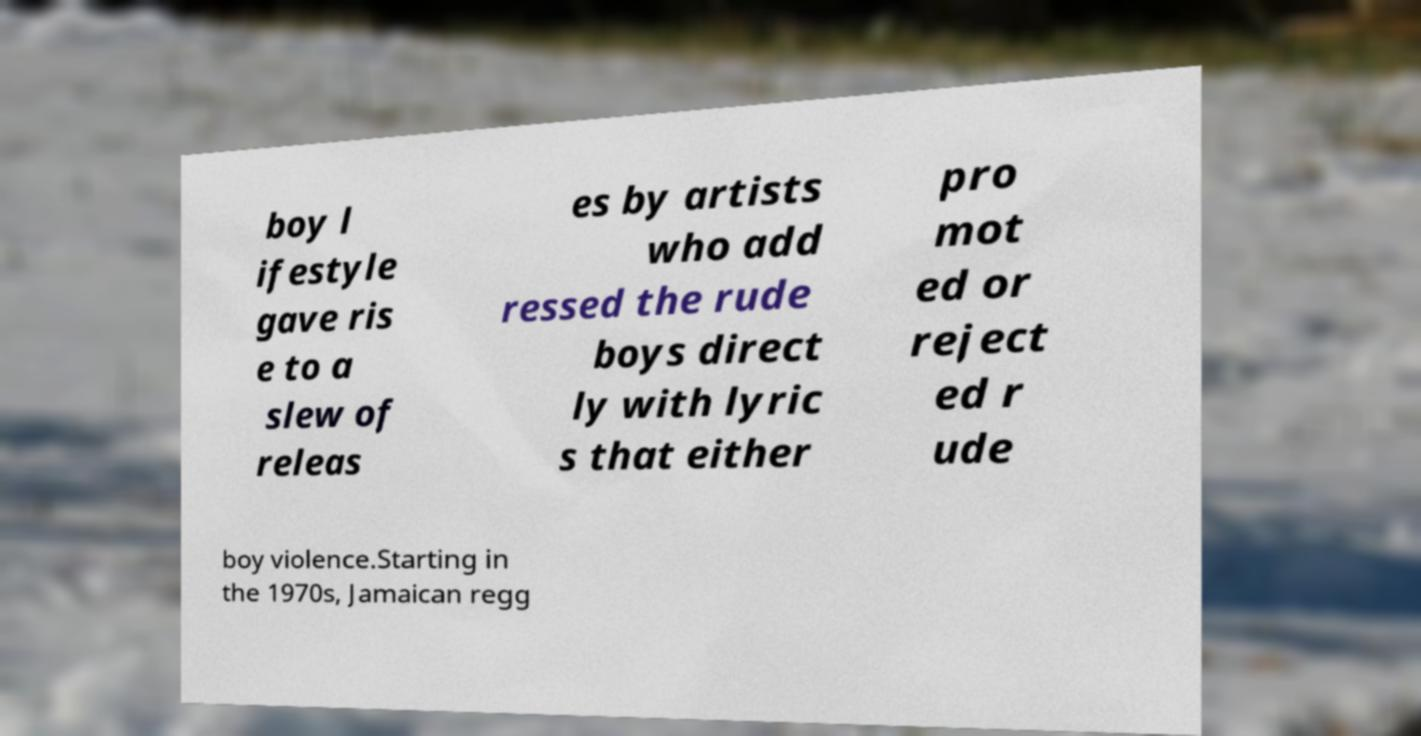What messages or text are displayed in this image? I need them in a readable, typed format. boy l ifestyle gave ris e to a slew of releas es by artists who add ressed the rude boys direct ly with lyric s that either pro mot ed or reject ed r ude boy violence.Starting in the 1970s, Jamaican regg 